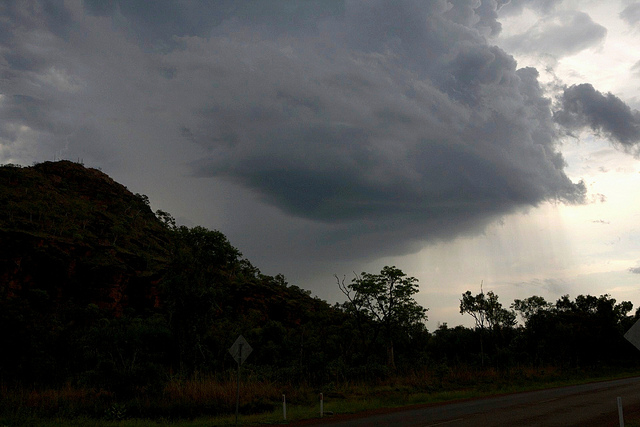<image>Where is this picture taken? It is unknown where the picture is taken. It could be in a forest, mountains, country, or outside. Where is the fire hydrant? It is unknown where the fire hydrant is. It may not be in the image. What does the road sign mean? It is unknown what the road sign means as it can't be seen. Where is this picture taken? It is not clear where the picture is taken. It can be in the forest, mountains, or outside in the country. Where is the fire hydrant? The fire hydrant is nowhere to be seen in the image. What does the road sign mean? I don't know what does the road sign mean. It seems to be either 'yield' or 'stop'. 